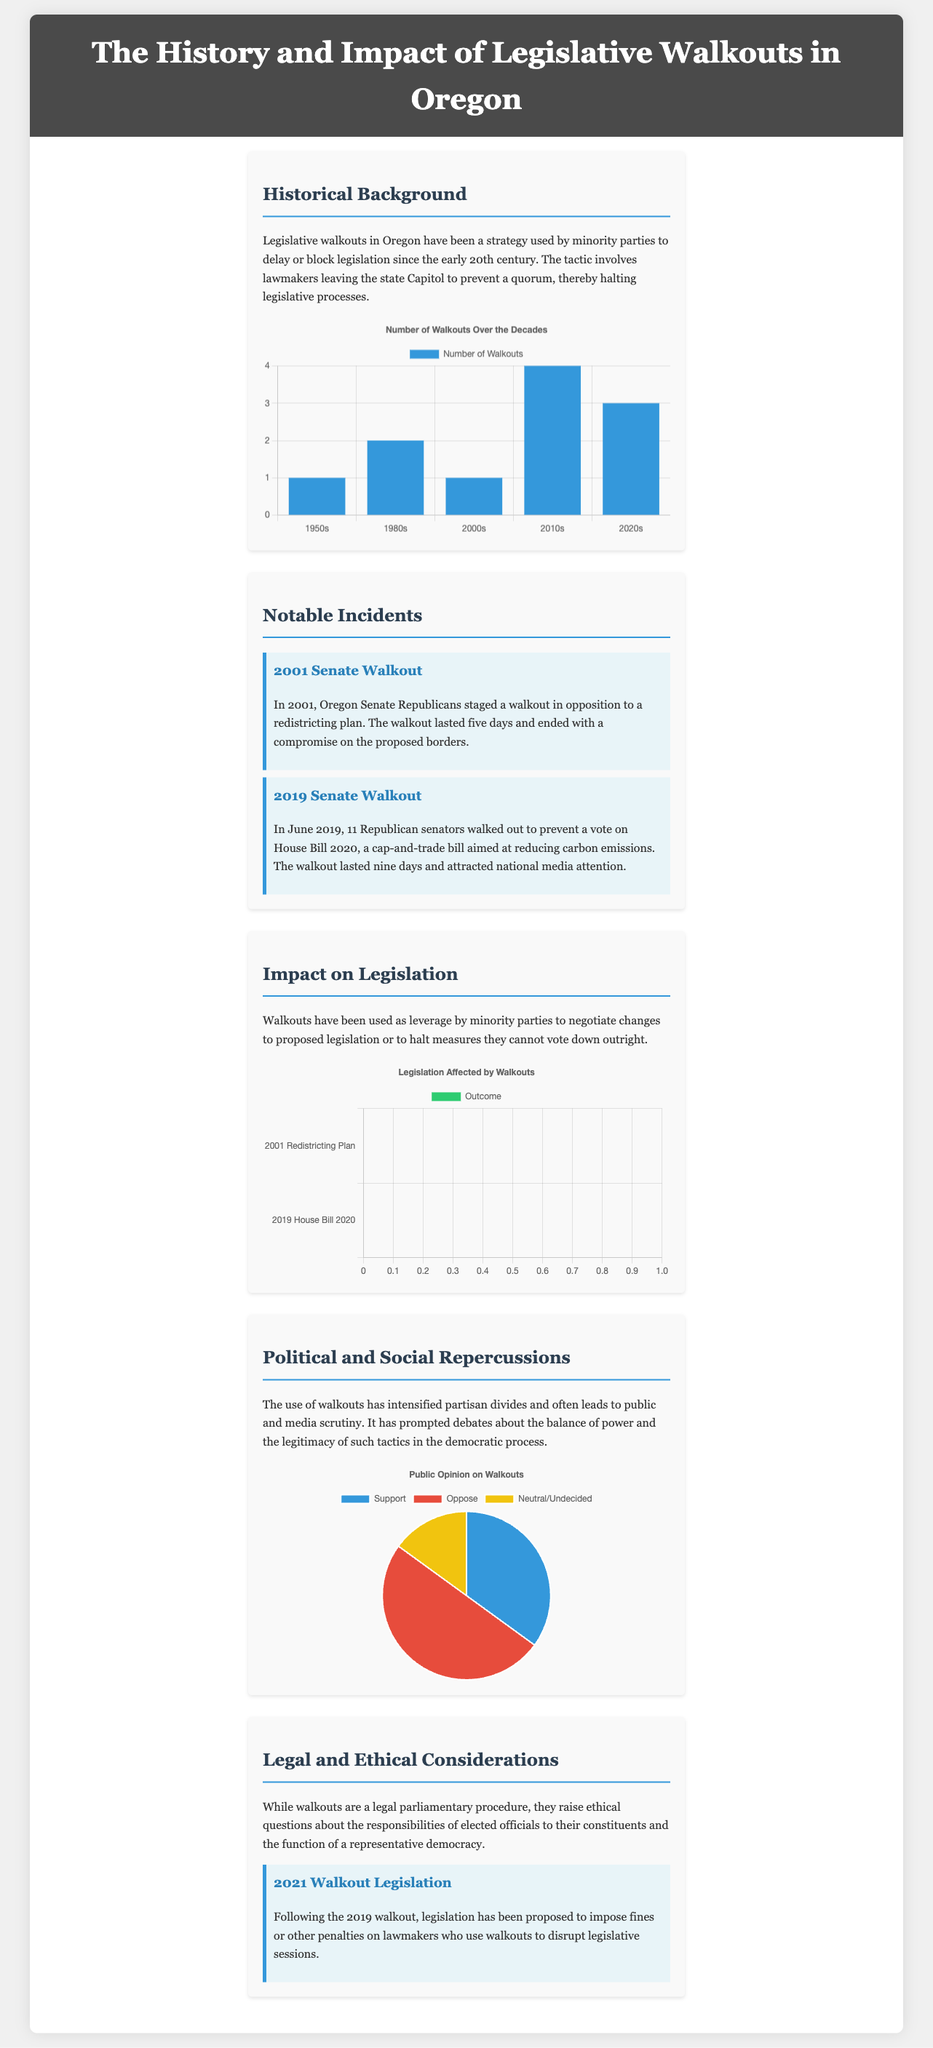What is the first decade in which legislative walkouts were recorded? The document states that legislative walkouts have been occurring since the early 20th century, which includes the 1950s.
Answer: 1950s How many walkouts occurred in the 2010s? The chart displays the number of walkouts over the decades, showing that there were four in the 2010s.
Answer: 4 What was the outcome of the 2001 Redistricting Plan walkout? The document describes that the 2001 Senate walkout ended with a compromise on the proposed borders.
Answer: Compromised How long did the 2019 Senate walkout last? The document states that the 2019 Senate walkout lasted nine days.
Answer: Nine days What percentage of the public opposes legislative walkouts? The pie chart shows that 50% of the public opposes them.
Answer: 50% How many walkouts were recorded in the 1980s? According to the chart, there were two walkouts recorded in the 1980s.
Answer: 2 What legislation was affected by the 2019 Senate walkout? The chart lists House Bill 2020 as the legislation affected by the 2019 Senate walkout.
Answer: House Bill 2020 What is a legal consideration raised by legislative walkouts? The document mentions that walkouts raise ethical questions about the responsibilities of elected officials.
Answer: Ethical questions What is the main purpose of a legislative walkout? The document states that the primary purpose is to delay or block legislation.
Answer: Delay or block legislation 